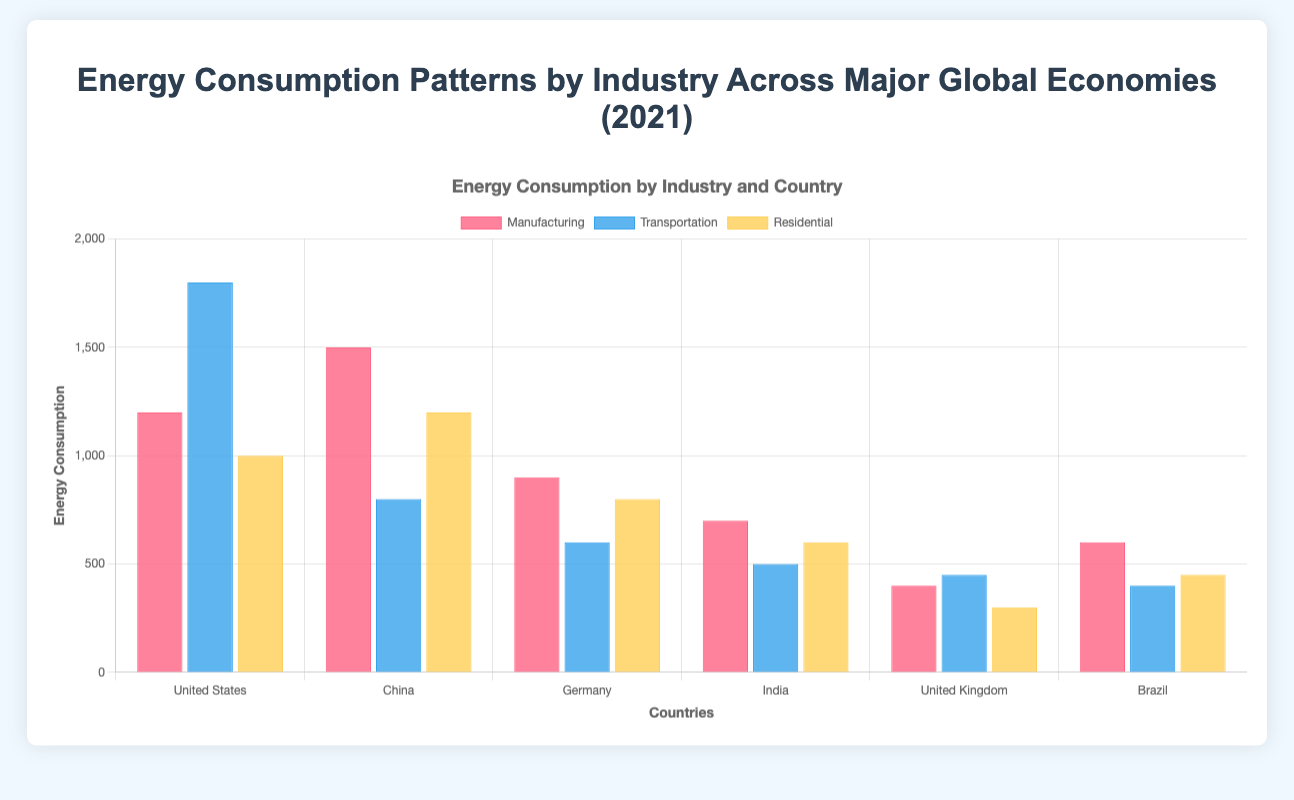What's the total energy consumption for the United States across all industries? Add the energy consumptions for Manufacturing (1200), Transportation (1800), and Residential (1000). The total is 1200 + 1800 + 1000 = 4000 units.
Answer: 4000 units Which country has the highest energy consumption in the Transportation industry? Check the energy consumption for the Transportation industry across all countries. The United States has the highest value at 1800 units.
Answer: United States In which industry does China consume the most energy? Compare the energy consumption of China across Manufacturing (1500), Transportation (800), and Residential (1200). Manufacturing has the highest consumption at 1500 units.
Answer: Manufacturing How does Germany's energy consumption in Manufacturing compare to India's? Germany consumes 900 units in Manufacturing, while India consumes 700 units. Hence, Germany's consumption is higher by 200 units.
Answer: Germany's is higher by 200 units What's the average energy consumption for the Residential sector across all countries? Sum the energy consumptions for Residential: 1000 (US) + 1200 (China) + 800 (Germany) + 600 (India) + 300 (UK) + 450 (Brazil) = 4350. Now, divide by the number of countries (6). The average is 4350 / 6 = 725 units.
Answer: 725 units Which country has the lowest overall energy consumption? Calculate the total energy consumption for each country: US (4000), China (3500), Germany (2300), India (1800), UK (1150), and Brazil (1450). The UK has the lowest at 1150 units.
Answer: United Kingdom Which industry in Brazil consumes less energy, Manufacturing or Transportation? Check the energy consumption values for Brazil: Manufacturing (600) and Transportation (400). Transportation consumes less energy.
Answer: Transportation How many units of energy does Germany consume more in Transportation than India? Germany consumes 600 units in Transportation, while India uses 500 units. The difference is 600 - 500 = 100 units.
Answer: 100 units What is the color of the bars representing the Manufacturing industry? Check the visual representation of the Manufacturing industry bars. They are colored in red.
Answer: Red Which visual element indicates the scale of energy consumption on the y-axis? The y-axis has a scale indicating units of energy consumption starting from 0 to 2000 units, with ticks at intervals of 500 units.
Answer: Y-axis ticks and labels 